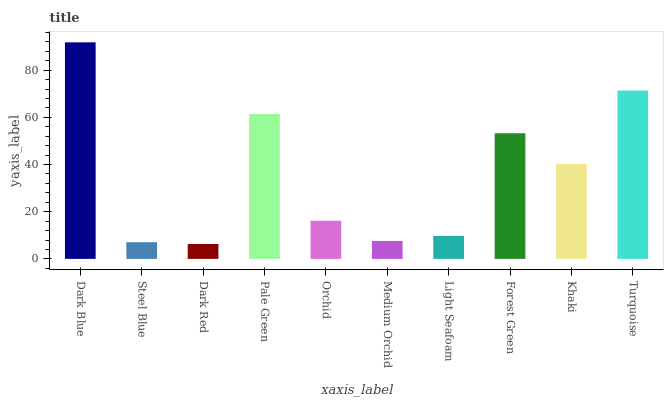Is Steel Blue the minimum?
Answer yes or no. No. Is Steel Blue the maximum?
Answer yes or no. No. Is Dark Blue greater than Steel Blue?
Answer yes or no. Yes. Is Steel Blue less than Dark Blue?
Answer yes or no. Yes. Is Steel Blue greater than Dark Blue?
Answer yes or no. No. Is Dark Blue less than Steel Blue?
Answer yes or no. No. Is Khaki the high median?
Answer yes or no. Yes. Is Orchid the low median?
Answer yes or no. Yes. Is Pale Green the high median?
Answer yes or no. No. Is Dark Red the low median?
Answer yes or no. No. 